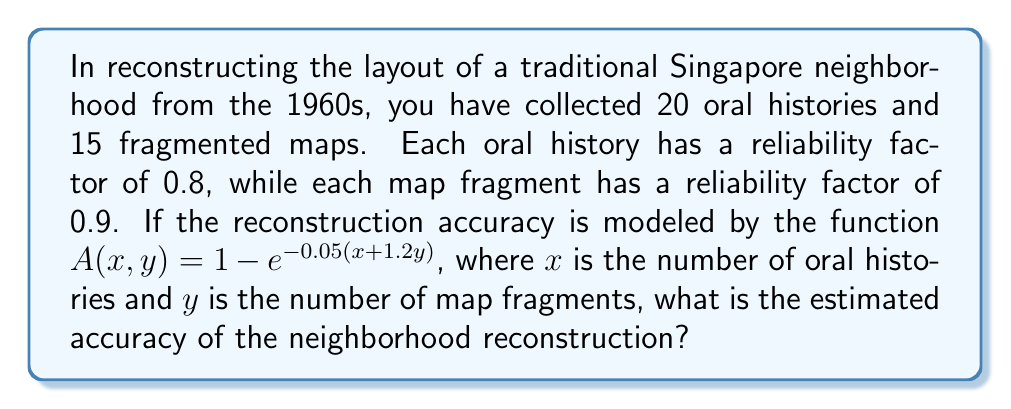Teach me how to tackle this problem. To solve this inverse problem, we'll follow these steps:

1. Identify the given information:
   - Number of oral histories: $x = 20$
   - Number of map fragments: $y = 15$
   - Accuracy function: $A(x, y) = 1 - e^{-0.05(x + 1.2y)}$

2. Substitute the values into the accuracy function:
   $A(20, 15) = 1 - e^{-0.05(20 + 1.2(15))}$

3. Simplify the expression inside the parentheses:
   $A(20, 15) = 1 - e^{-0.05(20 + 18)}$
   $A(20, 15) = 1 - e^{-0.05(38)}$

4. Calculate the exponent:
   $A(20, 15) = 1 - e^{-1.9}$

5. Use a calculator or computer to evaluate $e^{-1.9}$:
   $e^{-1.9} \approx 0.1496$

6. Subtract the result from 1:
   $A(20, 15) = 1 - 0.1496 \approx 0.8504$

7. Convert to a percentage:
   $0.8504 \times 100\% = 85.04\%$

Therefore, the estimated accuracy of the neighborhood reconstruction is approximately 85.04%.
Answer: 85.04% 